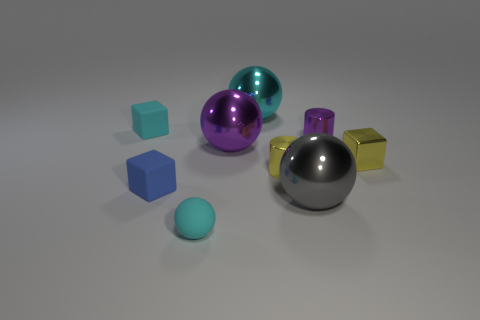Subtract all small metallic cubes. How many cubes are left? 2 Subtract all balls. How many objects are left? 5 Subtract 1 balls. How many balls are left? 3 Subtract all brown spheres. Subtract all purple cubes. How many spheres are left? 4 Subtract all blue blocks. How many yellow spheres are left? 0 Subtract all big cyan metal objects. Subtract all small purple rubber cylinders. How many objects are left? 8 Add 8 small purple objects. How many small purple objects are left? 9 Add 5 cylinders. How many cylinders exist? 7 Subtract all purple spheres. How many spheres are left? 3 Subtract 1 gray balls. How many objects are left? 8 